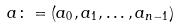Convert formula to latex. <formula><loc_0><loc_0><loc_500><loc_500>a \colon = ( a _ { 0 } , a _ { 1 } , \dots , a _ { n - 1 } )</formula> 